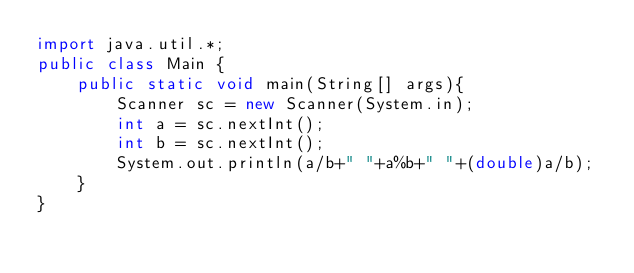<code> <loc_0><loc_0><loc_500><loc_500><_Java_>import java.util.*;
public class Main {
    public static void main(String[] args){
        Scanner sc = new Scanner(System.in);
        int a = sc.nextInt();
        int b = sc.nextInt();
        System.out.println(a/b+" "+a%b+" "+(double)a/b);
    }
}</code> 